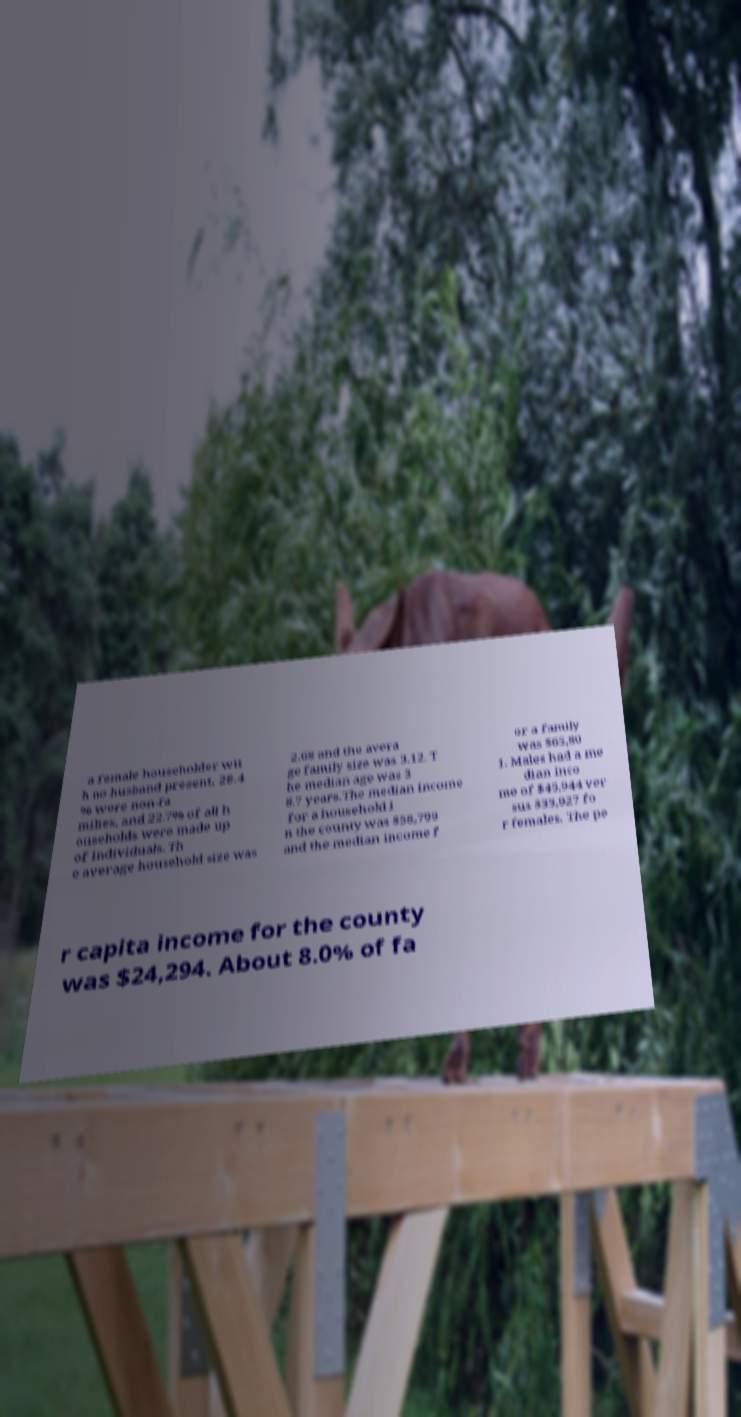I need the written content from this picture converted into text. Can you do that? a female householder wit h no husband present, 28.4 % were non-fa milies, and 22.7% of all h ouseholds were made up of individuals. Th e average household size was 2.68 and the avera ge family size was 3.12. T he median age was 3 8.7 years.The median income for a household i n the county was $58,799 and the median income f or a family was $65,80 1. Males had a me dian inco me of $45,944 ver sus $33,927 fo r females. The pe r capita income for the county was $24,294. About 8.0% of fa 